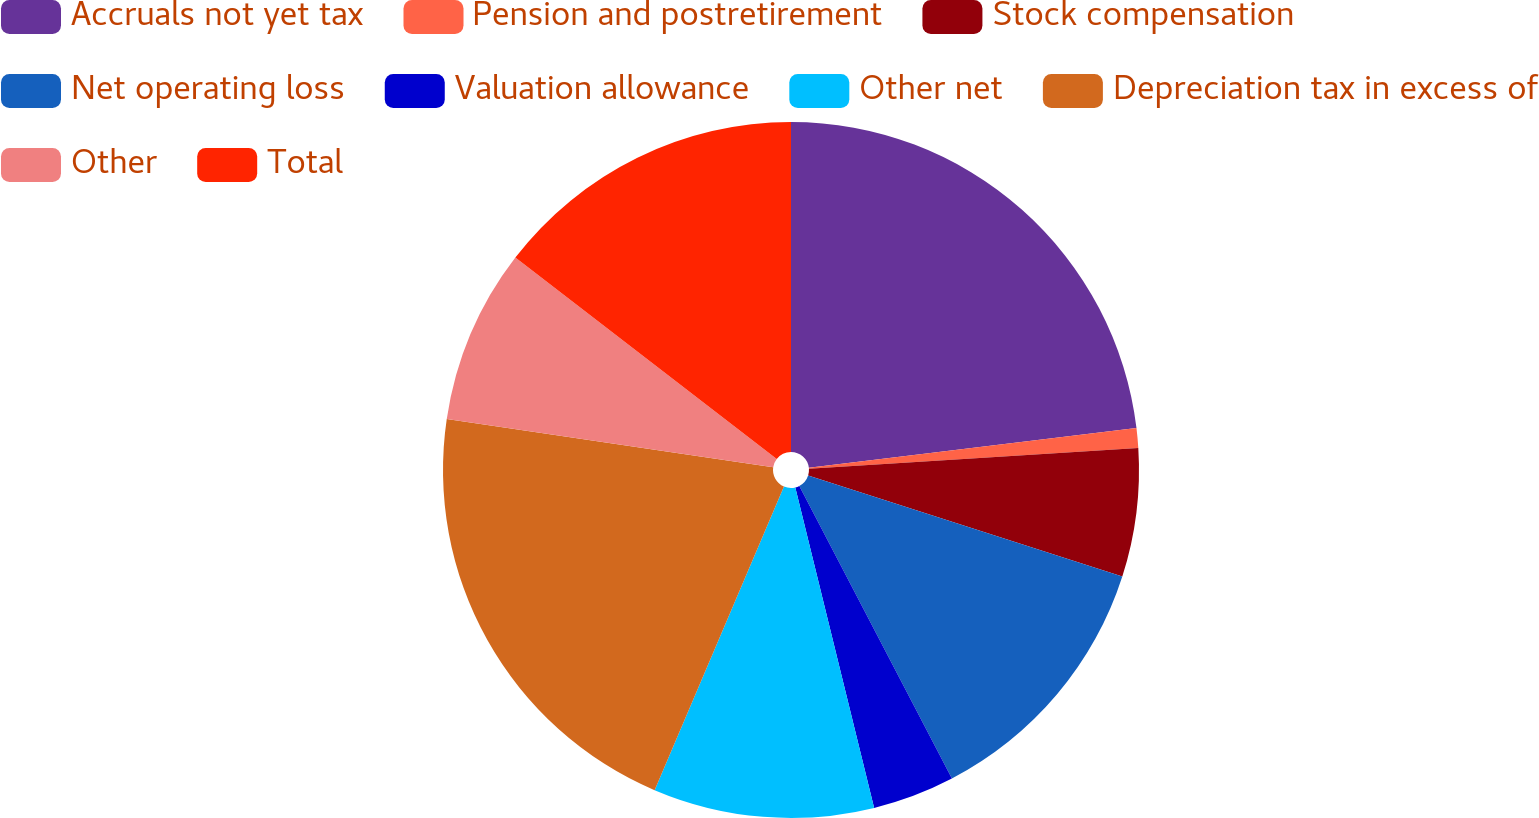Convert chart. <chart><loc_0><loc_0><loc_500><loc_500><pie_chart><fcel>Accruals not yet tax<fcel>Pension and postretirement<fcel>Stock compensation<fcel>Net operating loss<fcel>Valuation allowance<fcel>Other net<fcel>Depreciation tax in excess of<fcel>Other<fcel>Total<nl><fcel>23.08%<fcel>0.91%<fcel>5.96%<fcel>12.4%<fcel>3.81%<fcel>10.25%<fcel>20.93%<fcel>8.11%<fcel>14.55%<nl></chart> 